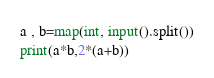Convert code to text. <code><loc_0><loc_0><loc_500><loc_500><_Python_>a , b=map(int, input().split())
print(a*b,2*(a+b))
</code> 